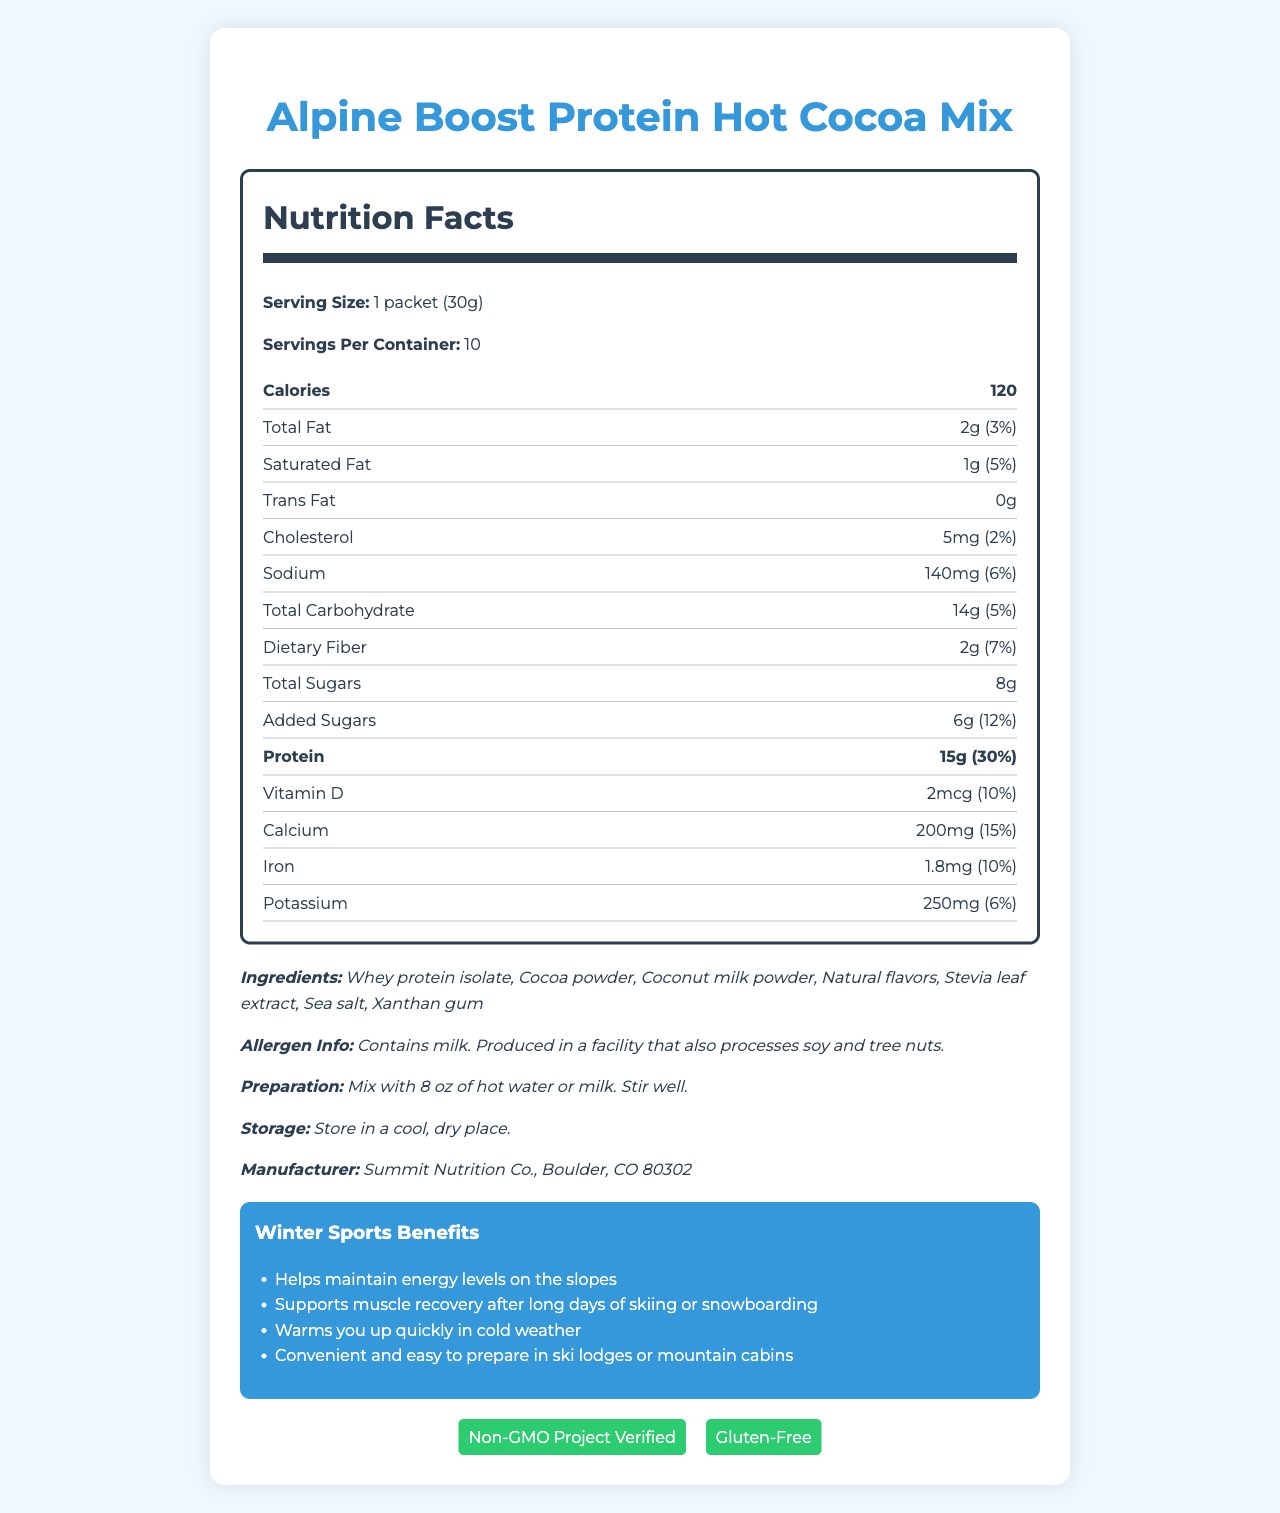what is the serving size of the Alpine Boost Protein Hot Cocoa Mix? The document clearly states that the serving size is "1 packet (30g)."
Answer: 1 packet (30g) How many calories are there per serving of this product? According to the document, each serving has 120 calories.
Answer: 120 Name three key ingredients in the Alpine Boost Protein Hot Cocoa Mix. The ingredients list includes: "Whey protein isolate, Cocoa powder, Coconut milk powder," among others.
Answer: Whey protein isolate, Cocoa powder, Coconut milk powder How much protein does one serving contain? The document specifies that each serving contains 15g of protein.
Answer: 15g What percentage of the daily value of added sugars is included in one serving? The document lists "added sugars" as having a daily value percentage of 12%.
Answer: 12% What are the total grams of carbohydrates in one serving? A. 12g B. 14g C. 18g D. 20g The document indicates that the total carbohydrate content per serving is 14g.
Answer: B. 14g How much calcium does one serving provide? A. 100mg B. 150mg C. 200mg D. 250mg The document states there are 200mg of calcium per serving.
Answer: C. 200mg Is this product Non-GMO and gluten-free? The document includes certifications for "Non-GMO Project Verified" and "Gluten-Free".
Answer: Yes Does this product contain any artificial sweeteners or preservatives? The document claims that the product has "No artificial sweeteners or preservatives."
Answer: No Summarize the main benefits of the Alpine Boost Protein Hot Cocoa Mix for winter sports enthusiasts. The document explains that the mix is beneficial for maintaining energy, supporting muscle recovery, warming up in cold weather, and being easy to make in suitable locations for winter sports enthusiasts.
Answer: The product provides high protein content (15g per serving), supports muscle recovery, helps maintain energy levels, warms you up quickly, and is convenient for preparation in settings like ski lodges or mountain cabins. How many packets are included in one container? The document states there are 10 servings per container, which corresponds to 10 packets.
Answer: 10 What is the main flavor profile of this hot cocoa mix? The document describes the flavor profile as "Rich, creamy chocolate with a hint of vanilla."
Answer: Rich, creamy chocolate with a hint of vanilla Can you determine the price of the Alpine Boost Protein Hot Cocoa Mix from this document? The document does not provide any information related to the price.
Answer: Not enough information 